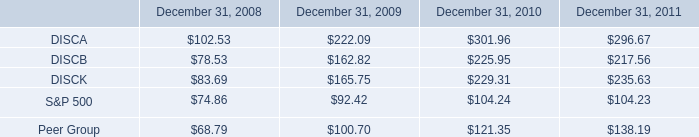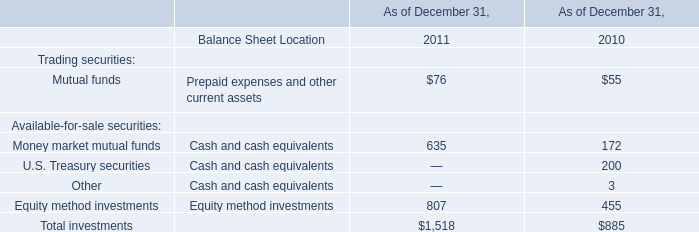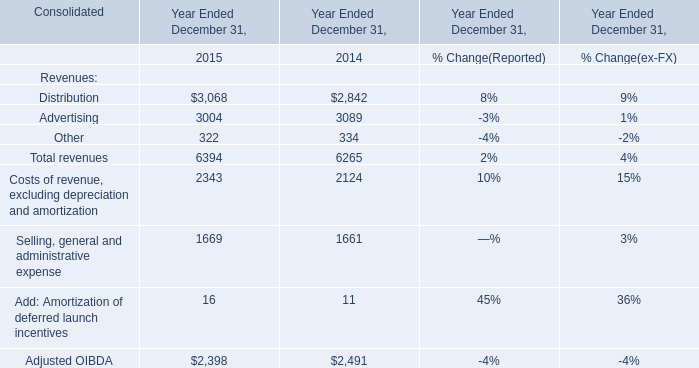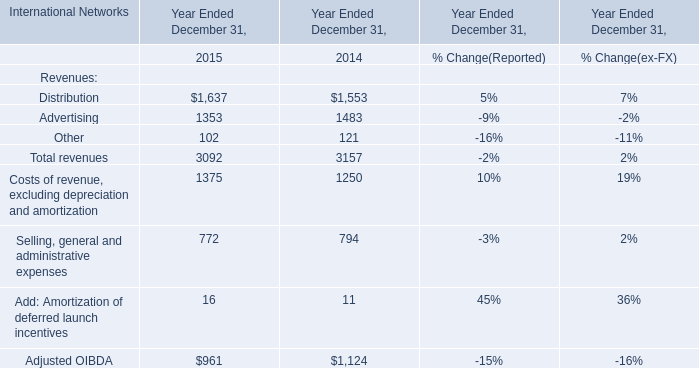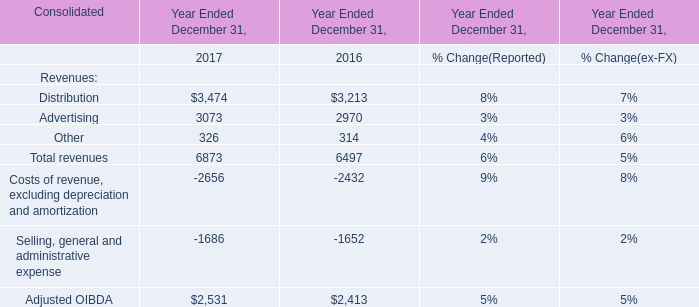What's the average of Advertising of Year Ended December 31, 2014, and Advertising of Year Ended December 31, 2015 ? 
Computations: ((3089.0 + 1353.0) / 2)
Answer: 2221.0. 